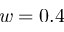Convert formula to latex. <formula><loc_0><loc_0><loc_500><loc_500>w = 0 . 4</formula> 